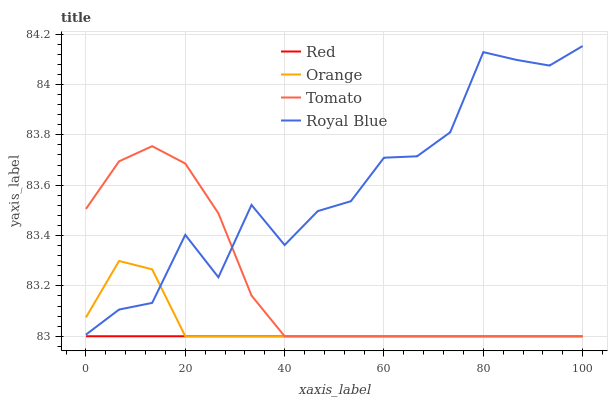Does Red have the minimum area under the curve?
Answer yes or no. Yes. Does Tomato have the minimum area under the curve?
Answer yes or no. No. Does Tomato have the maximum area under the curve?
Answer yes or no. No. Is Tomato the smoothest?
Answer yes or no. No. Is Tomato the roughest?
Answer yes or no. No. Does Royal Blue have the lowest value?
Answer yes or no. No. Does Tomato have the highest value?
Answer yes or no. No. Is Red less than Royal Blue?
Answer yes or no. Yes. Is Royal Blue greater than Red?
Answer yes or no. Yes. Does Red intersect Royal Blue?
Answer yes or no. No. 